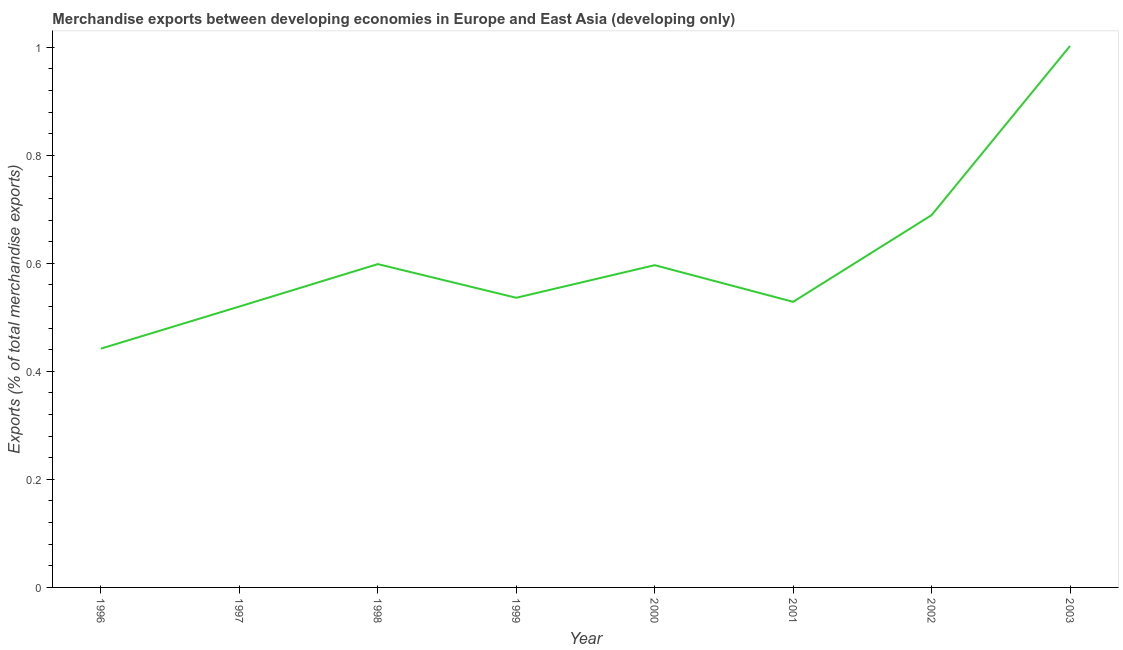What is the merchandise exports in 1996?
Make the answer very short. 0.44. Across all years, what is the maximum merchandise exports?
Your answer should be compact. 1. Across all years, what is the minimum merchandise exports?
Your answer should be compact. 0.44. In which year was the merchandise exports maximum?
Provide a short and direct response. 2003. What is the sum of the merchandise exports?
Your answer should be very brief. 4.91. What is the difference between the merchandise exports in 1996 and 2001?
Make the answer very short. -0.09. What is the average merchandise exports per year?
Give a very brief answer. 0.61. What is the median merchandise exports?
Make the answer very short. 0.57. What is the ratio of the merchandise exports in 1999 to that in 2000?
Ensure brevity in your answer.  0.9. What is the difference between the highest and the second highest merchandise exports?
Offer a very short reply. 0.31. Is the sum of the merchandise exports in 1997 and 2002 greater than the maximum merchandise exports across all years?
Offer a terse response. Yes. What is the difference between the highest and the lowest merchandise exports?
Your response must be concise. 0.56. In how many years, is the merchandise exports greater than the average merchandise exports taken over all years?
Give a very brief answer. 2. Does the merchandise exports monotonically increase over the years?
Give a very brief answer. No. How many years are there in the graph?
Your answer should be compact. 8. What is the title of the graph?
Offer a terse response. Merchandise exports between developing economies in Europe and East Asia (developing only). What is the label or title of the Y-axis?
Give a very brief answer. Exports (% of total merchandise exports). What is the Exports (% of total merchandise exports) in 1996?
Your response must be concise. 0.44. What is the Exports (% of total merchandise exports) in 1997?
Ensure brevity in your answer.  0.52. What is the Exports (% of total merchandise exports) of 1998?
Give a very brief answer. 0.6. What is the Exports (% of total merchandise exports) in 1999?
Provide a short and direct response. 0.54. What is the Exports (% of total merchandise exports) of 2000?
Offer a terse response. 0.6. What is the Exports (% of total merchandise exports) in 2001?
Provide a short and direct response. 0.53. What is the Exports (% of total merchandise exports) in 2002?
Your answer should be compact. 0.69. What is the Exports (% of total merchandise exports) of 2003?
Offer a very short reply. 1. What is the difference between the Exports (% of total merchandise exports) in 1996 and 1997?
Keep it short and to the point. -0.08. What is the difference between the Exports (% of total merchandise exports) in 1996 and 1998?
Give a very brief answer. -0.16. What is the difference between the Exports (% of total merchandise exports) in 1996 and 1999?
Your response must be concise. -0.09. What is the difference between the Exports (% of total merchandise exports) in 1996 and 2000?
Keep it short and to the point. -0.15. What is the difference between the Exports (% of total merchandise exports) in 1996 and 2001?
Your answer should be compact. -0.09. What is the difference between the Exports (% of total merchandise exports) in 1996 and 2002?
Your answer should be very brief. -0.25. What is the difference between the Exports (% of total merchandise exports) in 1996 and 2003?
Your answer should be very brief. -0.56. What is the difference between the Exports (% of total merchandise exports) in 1997 and 1998?
Give a very brief answer. -0.08. What is the difference between the Exports (% of total merchandise exports) in 1997 and 1999?
Provide a succinct answer. -0.02. What is the difference between the Exports (% of total merchandise exports) in 1997 and 2000?
Your answer should be very brief. -0.08. What is the difference between the Exports (% of total merchandise exports) in 1997 and 2001?
Keep it short and to the point. -0.01. What is the difference between the Exports (% of total merchandise exports) in 1997 and 2002?
Your answer should be compact. -0.17. What is the difference between the Exports (% of total merchandise exports) in 1997 and 2003?
Make the answer very short. -0.48. What is the difference between the Exports (% of total merchandise exports) in 1998 and 1999?
Give a very brief answer. 0.06. What is the difference between the Exports (% of total merchandise exports) in 1998 and 2000?
Give a very brief answer. 0. What is the difference between the Exports (% of total merchandise exports) in 1998 and 2001?
Keep it short and to the point. 0.07. What is the difference between the Exports (% of total merchandise exports) in 1998 and 2002?
Give a very brief answer. -0.09. What is the difference between the Exports (% of total merchandise exports) in 1998 and 2003?
Your answer should be very brief. -0.4. What is the difference between the Exports (% of total merchandise exports) in 1999 and 2000?
Make the answer very short. -0.06. What is the difference between the Exports (% of total merchandise exports) in 1999 and 2001?
Keep it short and to the point. 0.01. What is the difference between the Exports (% of total merchandise exports) in 1999 and 2002?
Your response must be concise. -0.15. What is the difference between the Exports (% of total merchandise exports) in 1999 and 2003?
Ensure brevity in your answer.  -0.47. What is the difference between the Exports (% of total merchandise exports) in 2000 and 2001?
Give a very brief answer. 0.07. What is the difference between the Exports (% of total merchandise exports) in 2000 and 2002?
Keep it short and to the point. -0.09. What is the difference between the Exports (% of total merchandise exports) in 2000 and 2003?
Make the answer very short. -0.41. What is the difference between the Exports (% of total merchandise exports) in 2001 and 2002?
Provide a short and direct response. -0.16. What is the difference between the Exports (% of total merchandise exports) in 2001 and 2003?
Provide a short and direct response. -0.47. What is the difference between the Exports (% of total merchandise exports) in 2002 and 2003?
Your answer should be compact. -0.31. What is the ratio of the Exports (% of total merchandise exports) in 1996 to that in 1997?
Provide a succinct answer. 0.85. What is the ratio of the Exports (% of total merchandise exports) in 1996 to that in 1998?
Your answer should be compact. 0.74. What is the ratio of the Exports (% of total merchandise exports) in 1996 to that in 1999?
Your answer should be very brief. 0.82. What is the ratio of the Exports (% of total merchandise exports) in 1996 to that in 2000?
Your answer should be very brief. 0.74. What is the ratio of the Exports (% of total merchandise exports) in 1996 to that in 2001?
Your response must be concise. 0.84. What is the ratio of the Exports (% of total merchandise exports) in 1996 to that in 2002?
Give a very brief answer. 0.64. What is the ratio of the Exports (% of total merchandise exports) in 1996 to that in 2003?
Give a very brief answer. 0.44. What is the ratio of the Exports (% of total merchandise exports) in 1997 to that in 1998?
Keep it short and to the point. 0.87. What is the ratio of the Exports (% of total merchandise exports) in 1997 to that in 1999?
Ensure brevity in your answer.  0.97. What is the ratio of the Exports (% of total merchandise exports) in 1997 to that in 2000?
Ensure brevity in your answer.  0.87. What is the ratio of the Exports (% of total merchandise exports) in 1997 to that in 2001?
Your response must be concise. 0.98. What is the ratio of the Exports (% of total merchandise exports) in 1997 to that in 2002?
Give a very brief answer. 0.75. What is the ratio of the Exports (% of total merchandise exports) in 1997 to that in 2003?
Make the answer very short. 0.52. What is the ratio of the Exports (% of total merchandise exports) in 1998 to that in 1999?
Ensure brevity in your answer.  1.12. What is the ratio of the Exports (% of total merchandise exports) in 1998 to that in 2001?
Keep it short and to the point. 1.13. What is the ratio of the Exports (% of total merchandise exports) in 1998 to that in 2002?
Offer a very short reply. 0.87. What is the ratio of the Exports (% of total merchandise exports) in 1998 to that in 2003?
Keep it short and to the point. 0.6. What is the ratio of the Exports (% of total merchandise exports) in 1999 to that in 2000?
Keep it short and to the point. 0.9. What is the ratio of the Exports (% of total merchandise exports) in 1999 to that in 2002?
Keep it short and to the point. 0.78. What is the ratio of the Exports (% of total merchandise exports) in 1999 to that in 2003?
Your answer should be compact. 0.54. What is the ratio of the Exports (% of total merchandise exports) in 2000 to that in 2001?
Give a very brief answer. 1.13. What is the ratio of the Exports (% of total merchandise exports) in 2000 to that in 2002?
Give a very brief answer. 0.87. What is the ratio of the Exports (% of total merchandise exports) in 2000 to that in 2003?
Give a very brief answer. 0.59. What is the ratio of the Exports (% of total merchandise exports) in 2001 to that in 2002?
Your answer should be very brief. 0.77. What is the ratio of the Exports (% of total merchandise exports) in 2001 to that in 2003?
Make the answer very short. 0.53. What is the ratio of the Exports (% of total merchandise exports) in 2002 to that in 2003?
Keep it short and to the point. 0.69. 